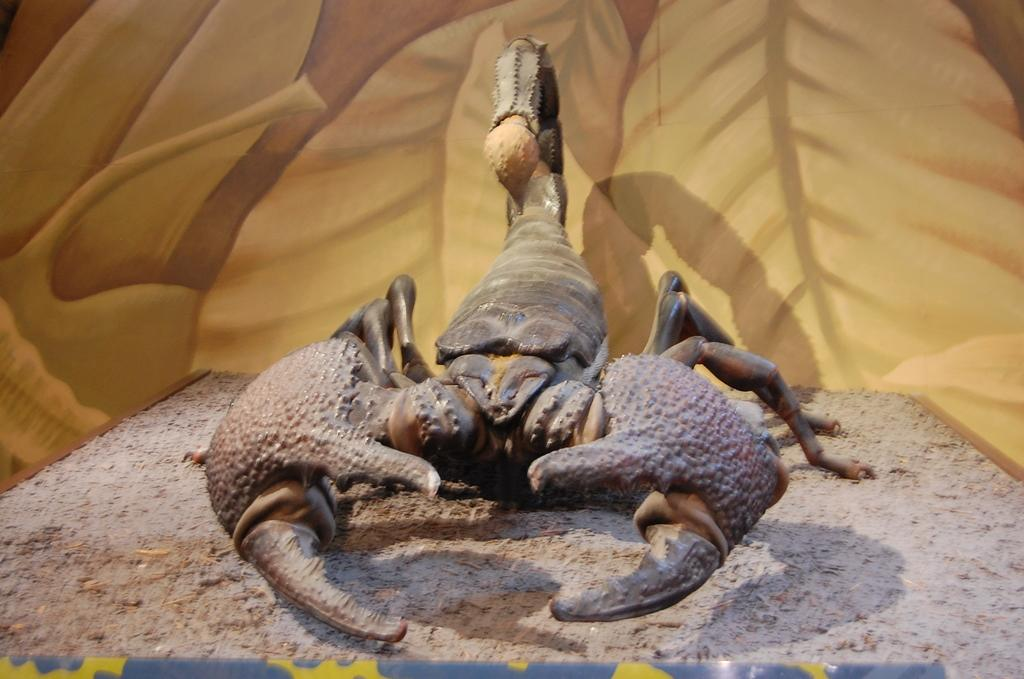What is placed on the ground in the image? There is an insert on the ground in the image. Can you describe anything behind the insert? There is a plastic thing visible behind the insert. What type of company is represented by the pickle in the image? There is no pickle present in the image, so it is not possible to determine if a company is represented. 